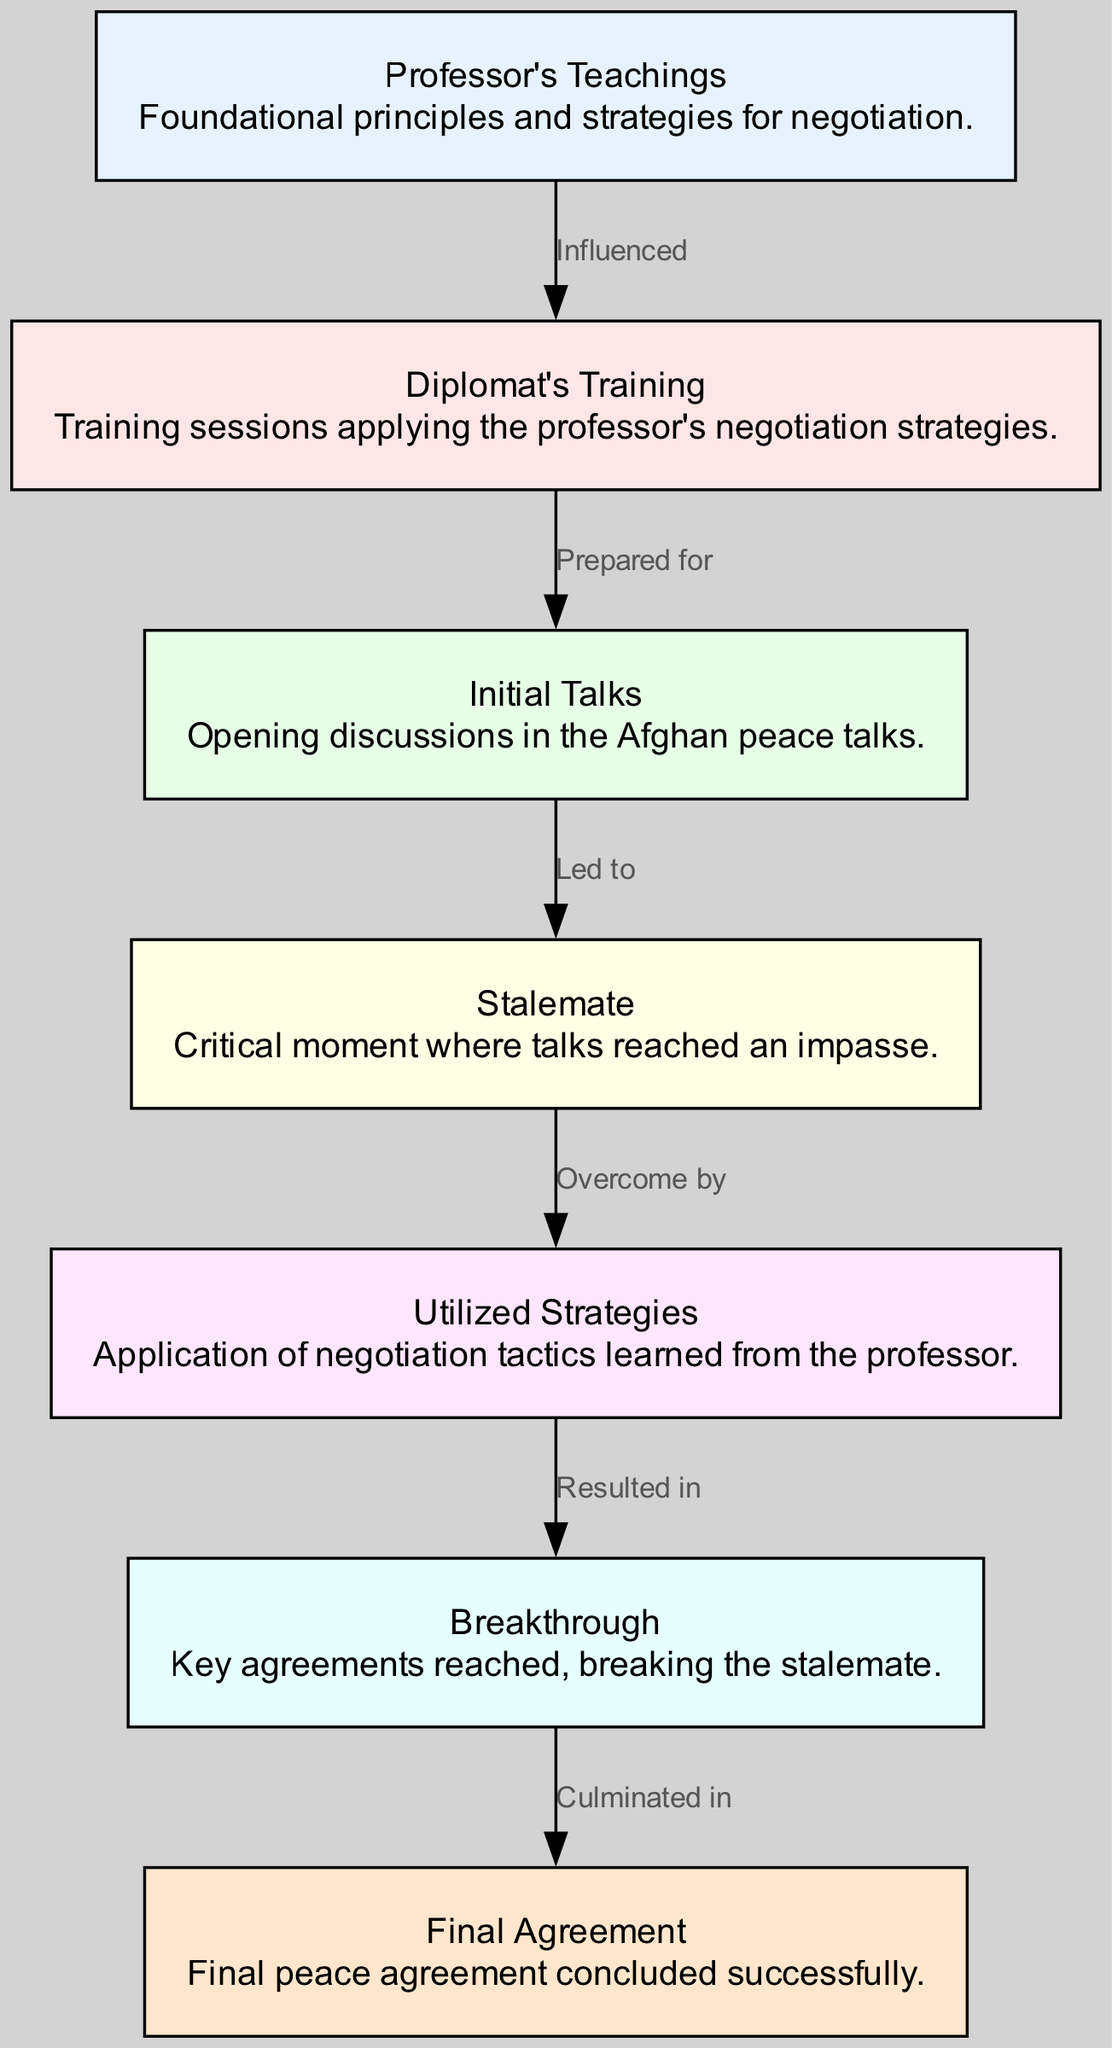What is the starting point of the sequence in the diagram? The diagram indicates that the starting point is the "Professor's Teachings," which serves as the foundation for subsequent nodes.
Answer: Professor's Teachings How many nodes are present in the diagram? By counting the nodes listed in the data, there are seven distinct nodes representing different stages of the negotiation process.
Answer: 7 What does the edge from "Stalemate" to "Utilized Strategies" signify? The edge represents that the stalemate in negotiations was overcome by applying the strategies learned from the professor's teachings.
Answer: Overcome by Which node follows "Breakthrough" in the sequence? The edge leading from "Breakthrough" connects directly to "Final Agreement," indicating that the breakthrough resulted in the final peace agreement.
Answer: Final Agreement What relationship does "Diplomat's Training" have with "Initial Talks"? The edge indicates that "Diplomat's Training" prepared the diplomat for the "Initial Talks," establishing a preparatory relationship between the two nodes.
Answer: Prepared for What is the outcome of applying "Utilized Strategies"? The application of the utilized strategies directly resulted in a "Breakthrough," showcasing the effective use of negotiation tactics.
Answer: Resulted in Which teaching influenced the "Diplomat's Training"? The "Diplomat's Training" was influenced by the "Professor's Teachings," which provided foundational strategies for negotiation tactics.
Answer: Influenced What led to the "Stalemate"? The "Initial Talks" led to the stalemate, indicating that the opening discussions reached an impasse during negotiations.
Answer: Led to 